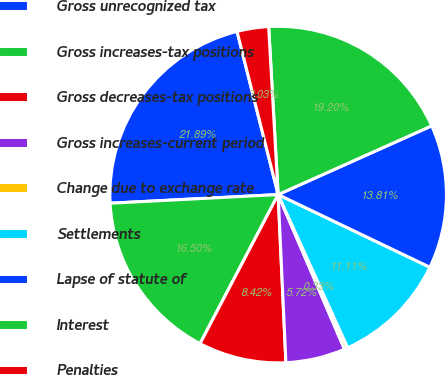Convert chart. <chart><loc_0><loc_0><loc_500><loc_500><pie_chart><fcel>Gross unrecognized tax<fcel>Gross increases-tax positions<fcel>Gross decreases-tax positions<fcel>Gross increases-current period<fcel>Change due to exchange rate<fcel>Settlements<fcel>Lapse of statute of<fcel>Interest<fcel>Penalties<nl><fcel>21.89%<fcel>16.5%<fcel>8.42%<fcel>5.72%<fcel>0.33%<fcel>11.11%<fcel>13.81%<fcel>19.2%<fcel>3.03%<nl></chart> 